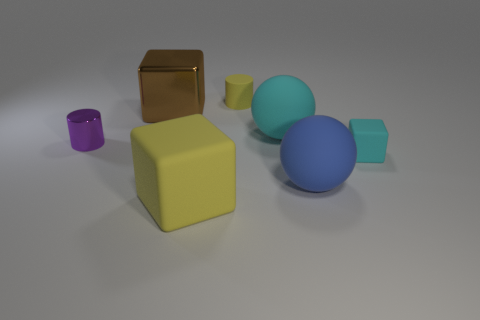Add 2 big yellow matte cubes. How many objects exist? 9 Subtract all cylinders. How many objects are left? 5 Add 3 big cyan rubber balls. How many big cyan rubber balls exist? 4 Subtract 0 brown cylinders. How many objects are left? 7 Subtract all tiny rubber cubes. Subtract all large brown cubes. How many objects are left? 5 Add 6 brown metallic blocks. How many brown metallic blocks are left? 7 